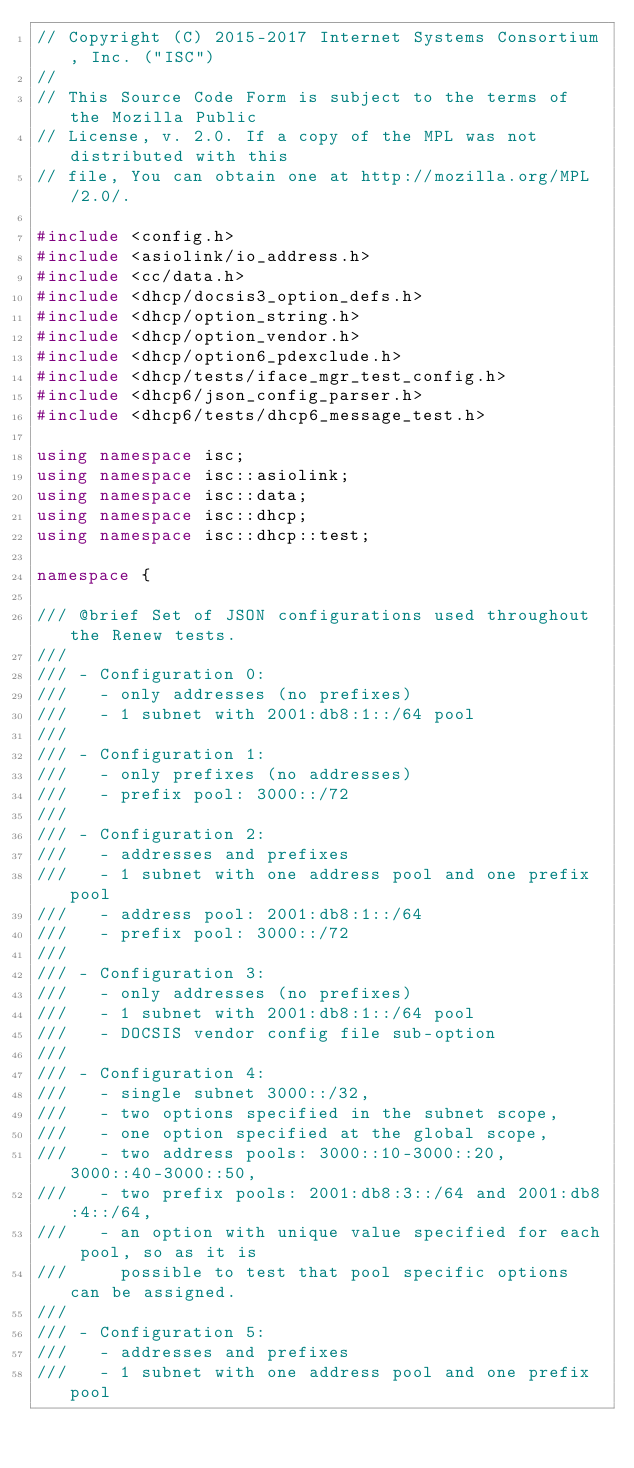Convert code to text. <code><loc_0><loc_0><loc_500><loc_500><_C++_>// Copyright (C) 2015-2017 Internet Systems Consortium, Inc. ("ISC")
//
// This Source Code Form is subject to the terms of the Mozilla Public
// License, v. 2.0. If a copy of the MPL was not distributed with this
// file, You can obtain one at http://mozilla.org/MPL/2.0/.

#include <config.h>
#include <asiolink/io_address.h>
#include <cc/data.h>
#include <dhcp/docsis3_option_defs.h>
#include <dhcp/option_string.h>
#include <dhcp/option_vendor.h>
#include <dhcp/option6_pdexclude.h>
#include <dhcp/tests/iface_mgr_test_config.h>
#include <dhcp6/json_config_parser.h>
#include <dhcp6/tests/dhcp6_message_test.h>

using namespace isc;
using namespace isc::asiolink;
using namespace isc::data;
using namespace isc::dhcp;
using namespace isc::dhcp::test;

namespace {

/// @brief Set of JSON configurations used throughout the Renew tests.
///
/// - Configuration 0:
///   - only addresses (no prefixes)
///   - 1 subnet with 2001:db8:1::/64 pool
///
/// - Configuration 1:
///   - only prefixes (no addresses)
///   - prefix pool: 3000::/72
///
/// - Configuration 2:
///   - addresses and prefixes
///   - 1 subnet with one address pool and one prefix pool
///   - address pool: 2001:db8:1::/64
///   - prefix pool: 3000::/72
///
/// - Configuration 3:
///   - only addresses (no prefixes)
///   - 1 subnet with 2001:db8:1::/64 pool
///   - DOCSIS vendor config file sub-option
///
/// - Configuration 4:
///   - single subnet 3000::/32,
///   - two options specified in the subnet scope,
///   - one option specified at the global scope,
///   - two address pools: 3000::10-3000::20, 3000::40-3000::50,
///   - two prefix pools: 2001:db8:3::/64 and 2001:db8:4::/64,
///   - an option with unique value specified for each pool, so as it is
///     possible to test that pool specific options can be assigned.
///
/// - Configuration 5:
///   - addresses and prefixes
///   - 1 subnet with one address pool and one prefix pool</code> 